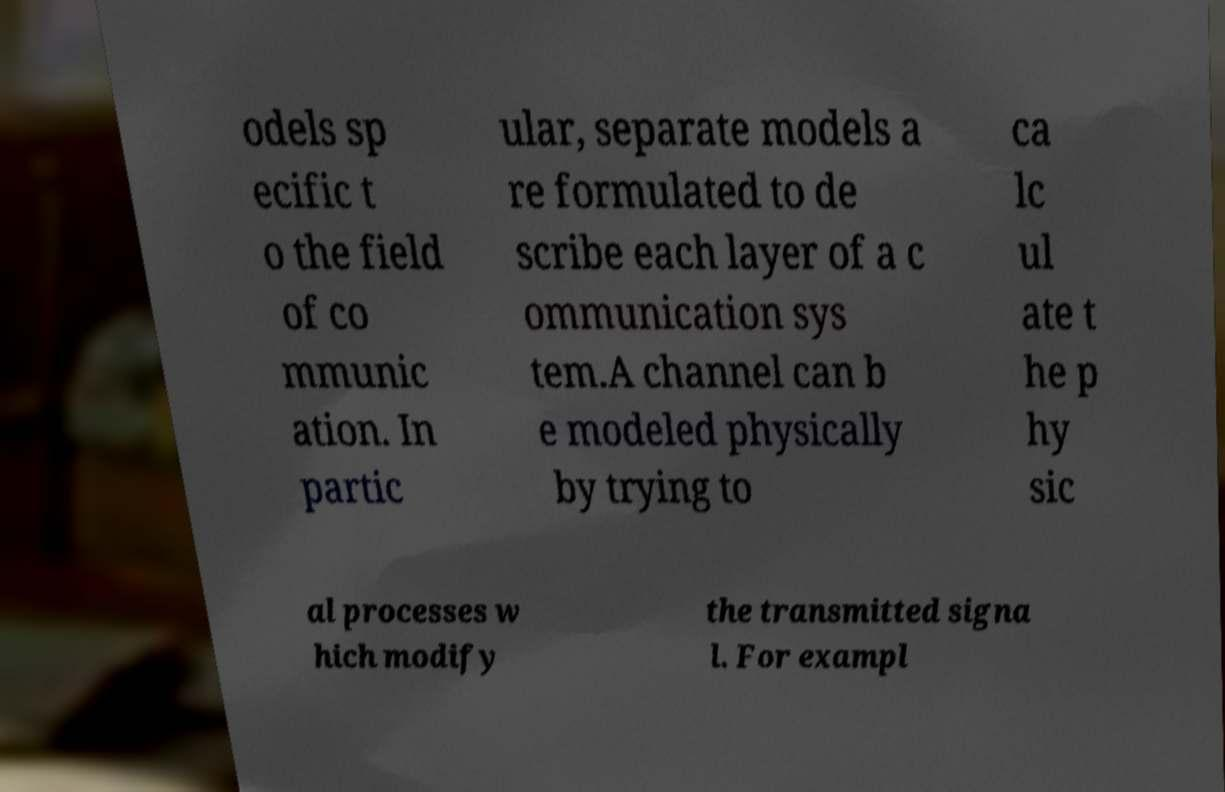Please read and relay the text visible in this image. What does it say? odels sp ecific t o the field of co mmunic ation. In partic ular, separate models a re formulated to de scribe each layer of a c ommunication sys tem.A channel can b e modeled physically by trying to ca lc ul ate t he p hy sic al processes w hich modify the transmitted signa l. For exampl 